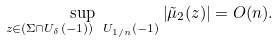Convert formula to latex. <formula><loc_0><loc_0><loc_500><loc_500>\sup _ { z \in ( \Sigma \cap U _ { \delta } ( - 1 ) ) \ U _ { 1 / n } ( - 1 ) } \left | \tilde { \mu } _ { 2 } ( z ) \right | = O ( n ) .</formula> 